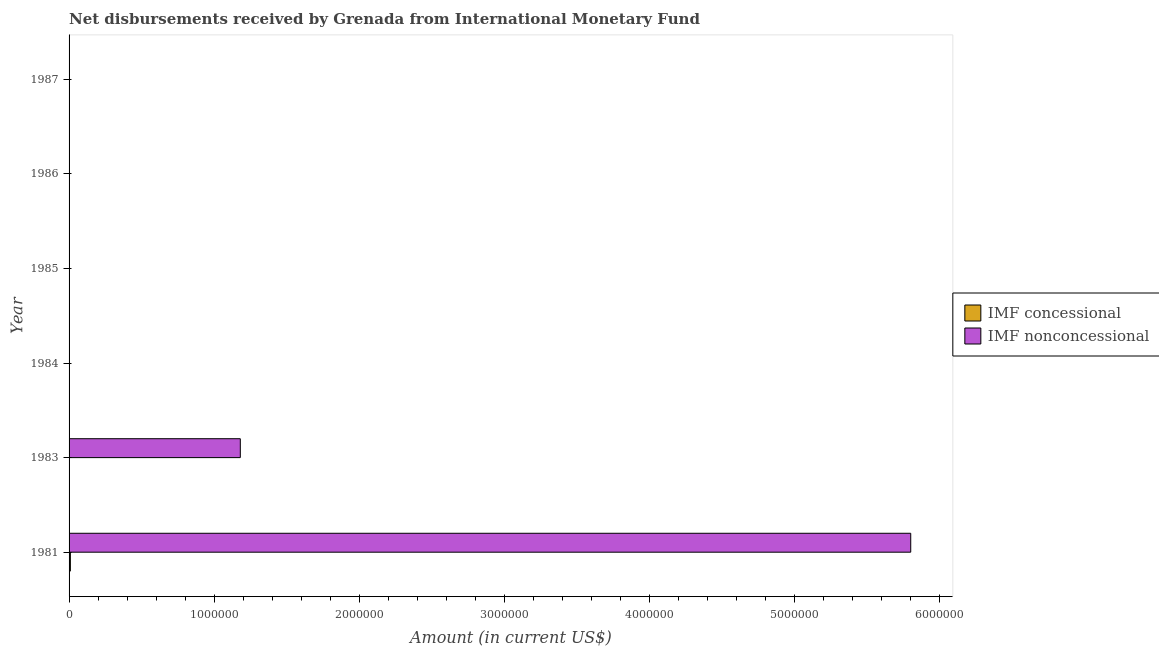How many different coloured bars are there?
Ensure brevity in your answer.  2. Are the number of bars per tick equal to the number of legend labels?
Provide a short and direct response. No. How many bars are there on the 4th tick from the bottom?
Your response must be concise. 0. What is the label of the 6th group of bars from the top?
Offer a very short reply. 1981. In how many cases, is the number of bars for a given year not equal to the number of legend labels?
Provide a short and direct response. 5. Across all years, what is the maximum net non concessional disbursements from imf?
Your answer should be very brief. 5.80e+06. Across all years, what is the minimum net non concessional disbursements from imf?
Your answer should be very brief. 0. In which year was the net non concessional disbursements from imf maximum?
Your answer should be compact. 1981. What is the total net concessional disbursements from imf in the graph?
Make the answer very short. 9000. What is the average net non concessional disbursements from imf per year?
Provide a short and direct response. 1.16e+06. In the year 1981, what is the difference between the net concessional disbursements from imf and net non concessional disbursements from imf?
Your answer should be very brief. -5.79e+06. In how many years, is the net concessional disbursements from imf greater than 4600000 US$?
Keep it short and to the point. 0. What is the difference between the highest and the lowest net non concessional disbursements from imf?
Your answer should be very brief. 5.80e+06. How many bars are there?
Your answer should be compact. 3. What is the difference between two consecutive major ticks on the X-axis?
Provide a short and direct response. 1.00e+06. Does the graph contain any zero values?
Offer a terse response. Yes. How many legend labels are there?
Provide a short and direct response. 2. What is the title of the graph?
Provide a succinct answer. Net disbursements received by Grenada from International Monetary Fund. Does "Mineral" appear as one of the legend labels in the graph?
Offer a very short reply. No. What is the label or title of the Y-axis?
Ensure brevity in your answer.  Year. What is the Amount (in current US$) in IMF concessional in 1981?
Provide a short and direct response. 9000. What is the Amount (in current US$) of IMF nonconcessional in 1981?
Provide a succinct answer. 5.80e+06. What is the Amount (in current US$) of IMF nonconcessional in 1983?
Your response must be concise. 1.18e+06. What is the Amount (in current US$) of IMF concessional in 1984?
Keep it short and to the point. 0. What is the Amount (in current US$) in IMF nonconcessional in 1984?
Offer a very short reply. 0. What is the Amount (in current US$) in IMF concessional in 1985?
Ensure brevity in your answer.  0. What is the Amount (in current US$) of IMF nonconcessional in 1987?
Provide a short and direct response. 0. Across all years, what is the maximum Amount (in current US$) of IMF concessional?
Offer a terse response. 9000. Across all years, what is the maximum Amount (in current US$) of IMF nonconcessional?
Make the answer very short. 5.80e+06. Across all years, what is the minimum Amount (in current US$) in IMF concessional?
Ensure brevity in your answer.  0. Across all years, what is the minimum Amount (in current US$) in IMF nonconcessional?
Keep it short and to the point. 0. What is the total Amount (in current US$) in IMF concessional in the graph?
Your answer should be very brief. 9000. What is the total Amount (in current US$) of IMF nonconcessional in the graph?
Make the answer very short. 6.98e+06. What is the difference between the Amount (in current US$) of IMF nonconcessional in 1981 and that in 1983?
Your response must be concise. 4.62e+06. What is the difference between the Amount (in current US$) in IMF concessional in 1981 and the Amount (in current US$) in IMF nonconcessional in 1983?
Offer a very short reply. -1.17e+06. What is the average Amount (in current US$) in IMF concessional per year?
Your answer should be very brief. 1500. What is the average Amount (in current US$) in IMF nonconcessional per year?
Provide a short and direct response. 1.16e+06. In the year 1981, what is the difference between the Amount (in current US$) of IMF concessional and Amount (in current US$) of IMF nonconcessional?
Provide a short and direct response. -5.79e+06. What is the ratio of the Amount (in current US$) of IMF nonconcessional in 1981 to that in 1983?
Your response must be concise. 4.92. What is the difference between the highest and the lowest Amount (in current US$) in IMF concessional?
Offer a terse response. 9000. What is the difference between the highest and the lowest Amount (in current US$) in IMF nonconcessional?
Provide a succinct answer. 5.80e+06. 